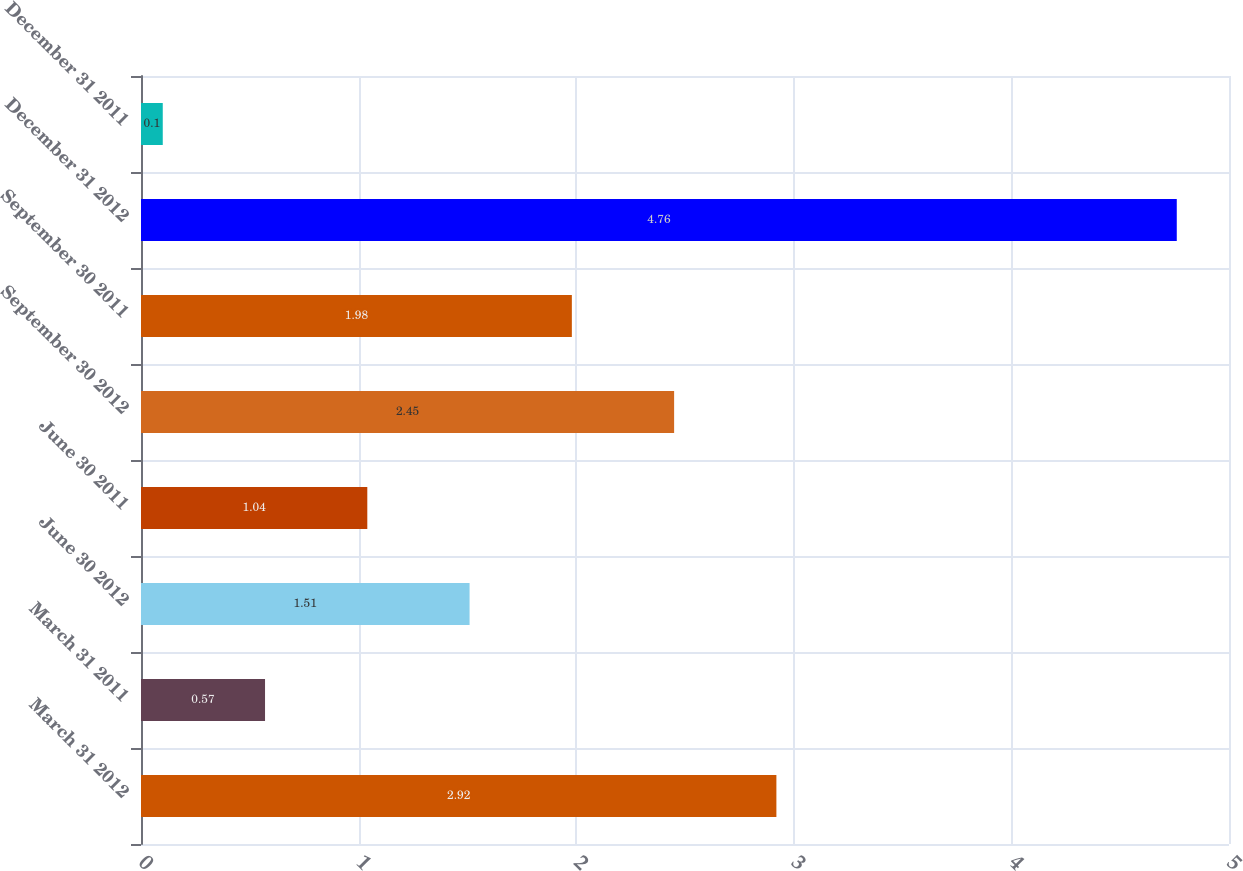Convert chart. <chart><loc_0><loc_0><loc_500><loc_500><bar_chart><fcel>March 31 2012<fcel>March 31 2011<fcel>June 30 2012<fcel>June 30 2011<fcel>September 30 2012<fcel>September 30 2011<fcel>December 31 2012<fcel>December 31 2011<nl><fcel>2.92<fcel>0.57<fcel>1.51<fcel>1.04<fcel>2.45<fcel>1.98<fcel>4.76<fcel>0.1<nl></chart> 